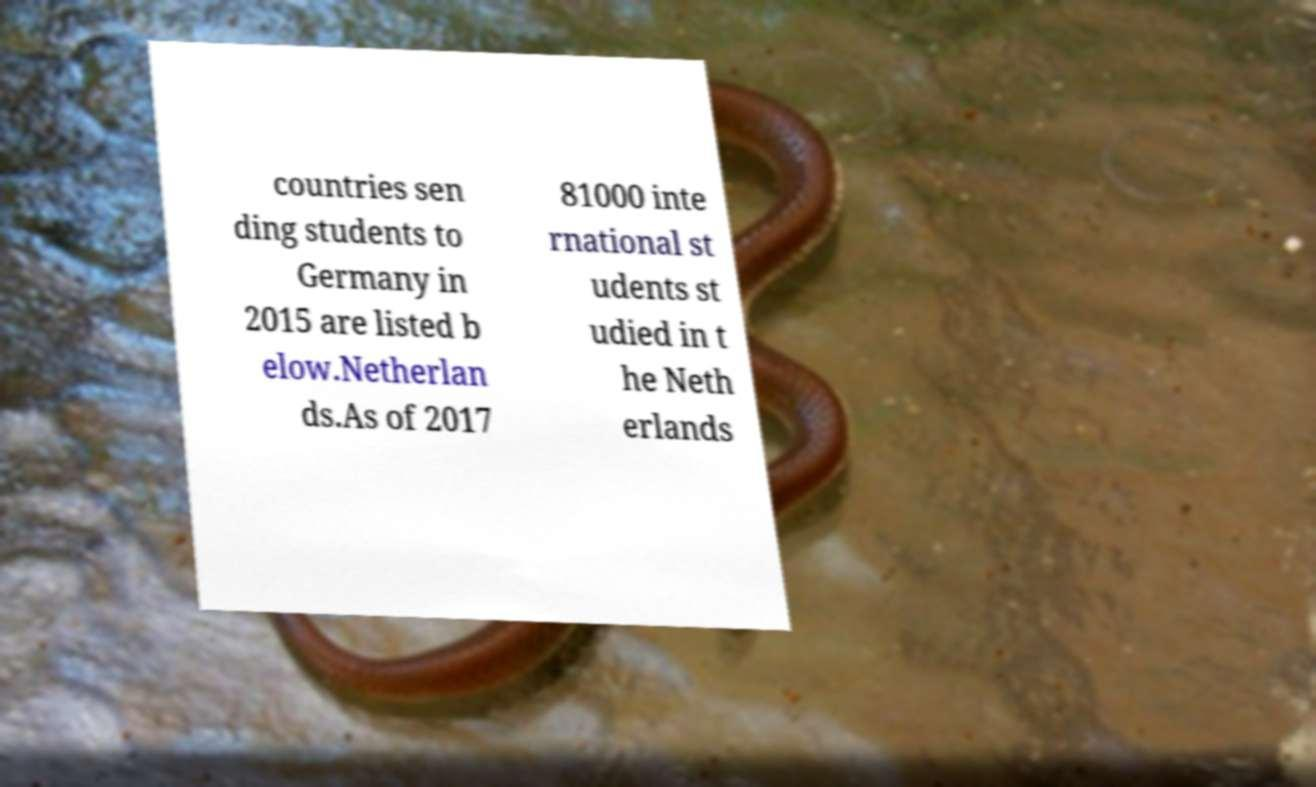There's text embedded in this image that I need extracted. Can you transcribe it verbatim? countries sen ding students to Germany in 2015 are listed b elow.Netherlan ds.As of 2017 81000 inte rnational st udents st udied in t he Neth erlands 